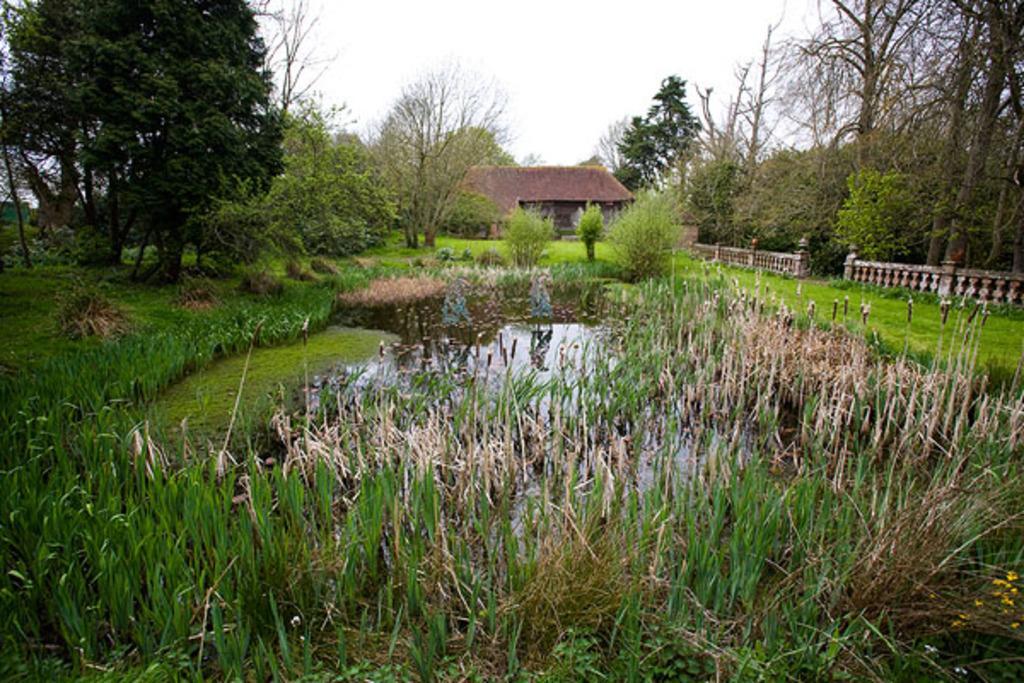In one or two sentences, can you explain what this image depicts? In this image there is a house in the background. In front of the house there is a garden. In the garden there are so many plants and trees. At the bottom there is grass. Beside the grass there is water. There are trees on either side of the house. At the top there is the sky. 